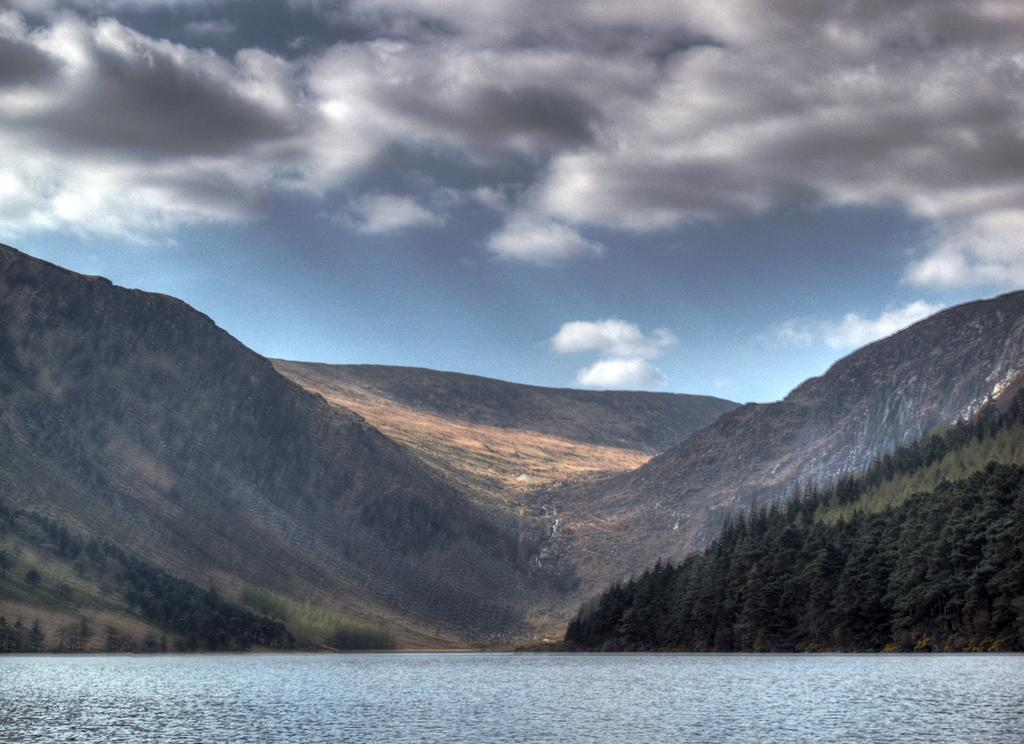What can be seen in the sky in the background of the image? There are clouds in the sky in the background of the image. What type of landscape features are visible in the background of the image? Hills and thicket are visible in the background of the image. What is present at the bottom portion of the image? There is water visible at the bottom portion of the image. What type of iron is visible in the image? There is no iron present in the image. Can you hear the voice of the person in the image? There is no person present in the image, so it is not possible to hear their voice. 